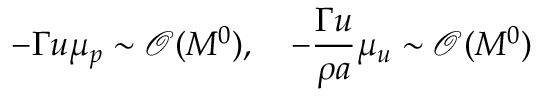<formula> <loc_0><loc_0><loc_500><loc_500>- \Gamma u \mu _ { p } \sim \mathcal { O } ( M ^ { 0 } ) , \quad - \frac { \Gamma u } { \rho a } \mu _ { u } \sim \mathcal { O } ( M ^ { 0 } )</formula> 